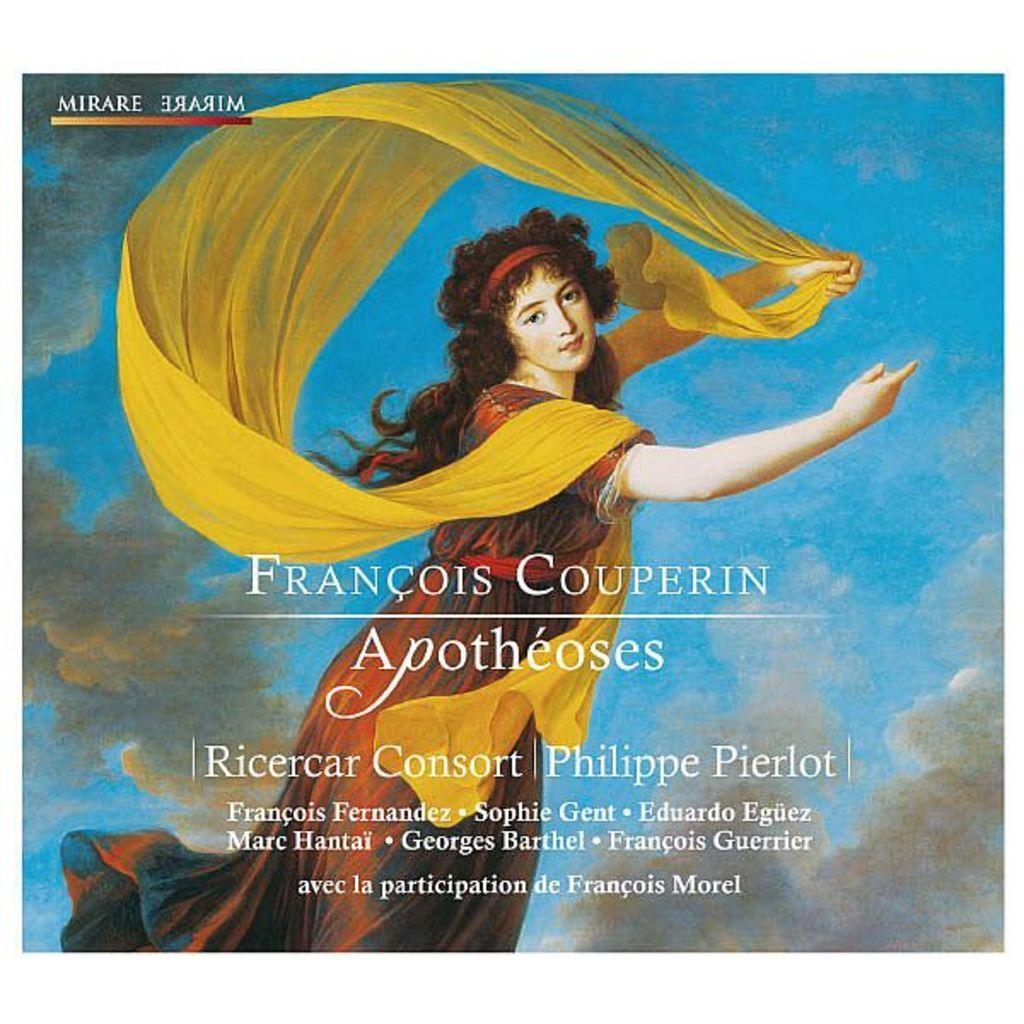<image>
Describe the image concisely. Album cover showing a woman in the clouds titled "Francois Couperin". 